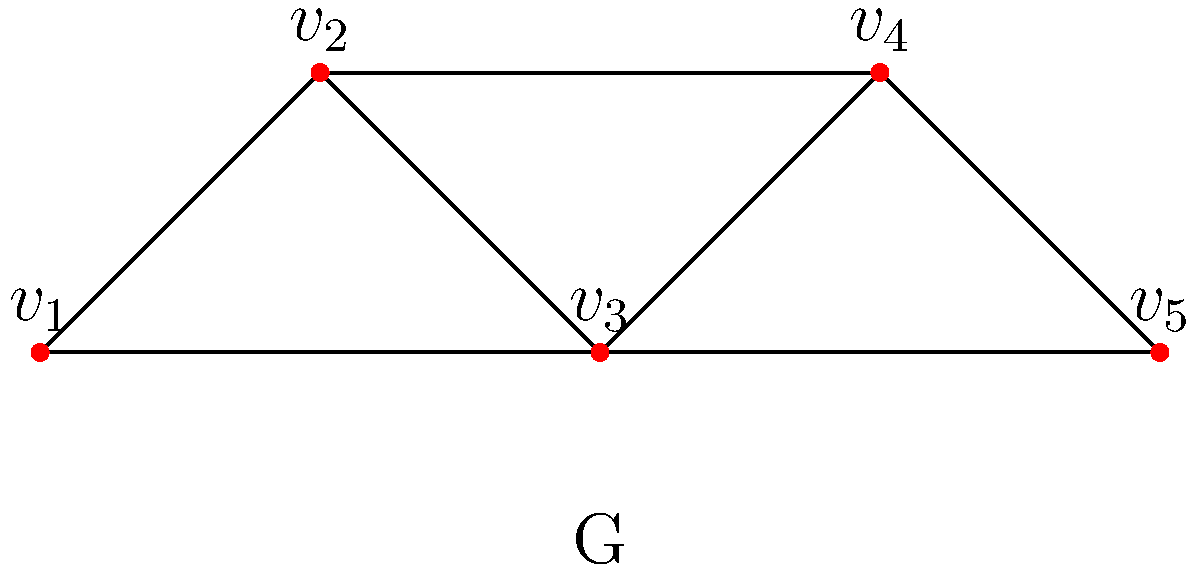Consider the graph G representing possible chess positions, where vertices represent positions and edges represent legal moves between positions. What is the vertex connectivity of G, and how does this relate to the robustness of the chess position network? To determine the vertex connectivity of graph G and its relation to the chess position network, we follow these steps:

1. Understand vertex connectivity: It's the minimum number of vertices that need to be removed to disconnect the graph.

2. Analyze the graph structure:
   - G has 5 vertices: $v_1$, $v_2$, $v_3$, $v_4$, and $v_5$
   - There are multiple paths between most vertex pairs

3. Identify critical vertices:
   - Removing $v_3$ disconnects the graph into two components: {$v_1$, $v_2$} and {$v_4$, $v_5$}
   - No single vertex other than $v_3$ can disconnect the graph

4. Determine vertex connectivity:
   - Since removing one vertex ($v_3$) can disconnect the graph, the vertex connectivity is 1

5. Relate to chess positions:
   - Vertex connectivity of 1 implies a "bottleneck" position ($v_3$)
   - This position is crucial for transitioning between two groups of positions
   - Low connectivity suggests the network is vulnerable to disconnection

6. Interpret robustness:
   - A higher vertex connectivity would indicate a more robust network
   - In this case, the low connectivity (1) suggests that the network of chess positions is not very robust
   - Removing the critical position ($v_3$) significantly limits the possible transitions between other positions
Answer: 1; indicates low robustness due to a critical "bottleneck" position 